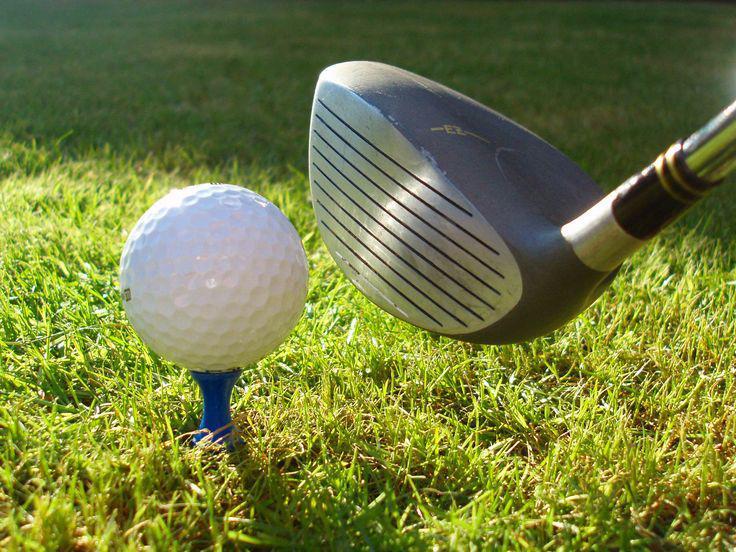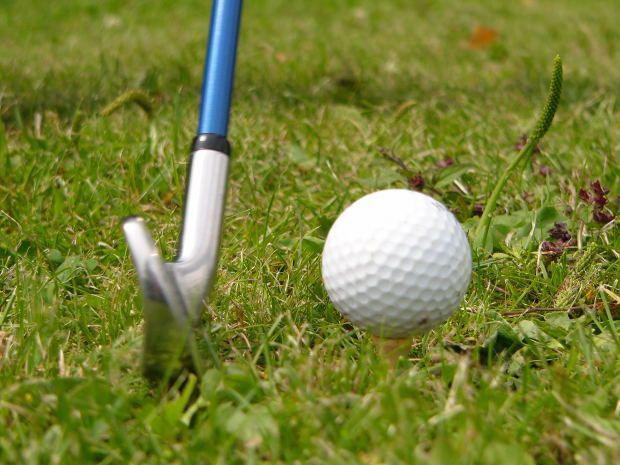The first image is the image on the left, the second image is the image on the right. For the images shown, is this caption "The golf ball in the left image is on a tee." true? Answer yes or no. Yes. 